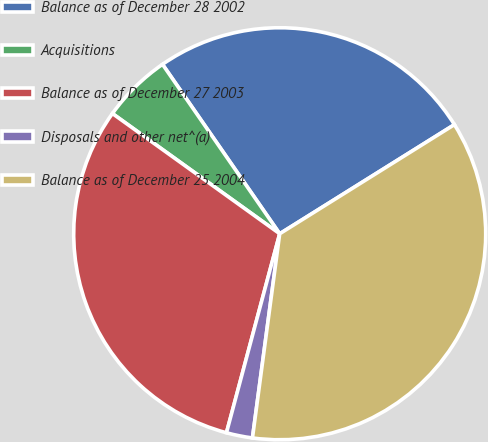<chart> <loc_0><loc_0><loc_500><loc_500><pie_chart><fcel>Balance as of December 28 2002<fcel>Acquisitions<fcel>Balance as of December 27 2003<fcel>Disposals and other net^(a)<fcel>Balance as of December 25 2004<nl><fcel>25.75%<fcel>5.45%<fcel>30.76%<fcel>2.05%<fcel>36.0%<nl></chart> 